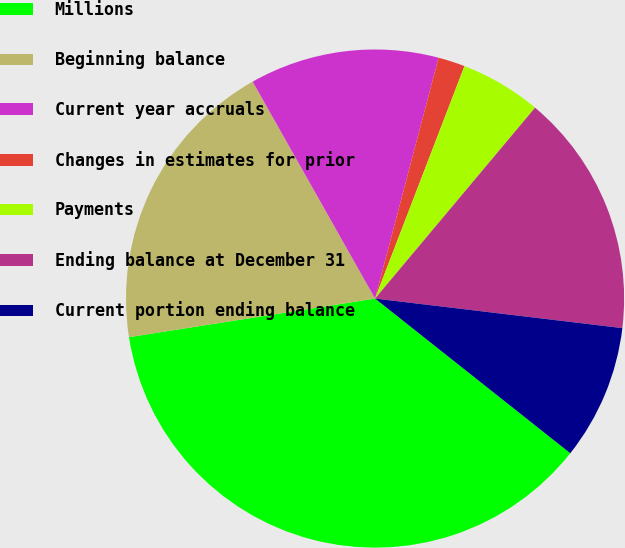Convert chart. <chart><loc_0><loc_0><loc_500><loc_500><pie_chart><fcel>Millions<fcel>Beginning balance<fcel>Current year accruals<fcel>Changes in estimates for prior<fcel>Payments<fcel>Ending balance at December 31<fcel>Current portion ending balance<nl><fcel>36.86%<fcel>19.3%<fcel>12.28%<fcel>1.74%<fcel>5.26%<fcel>15.79%<fcel>8.77%<nl></chart> 